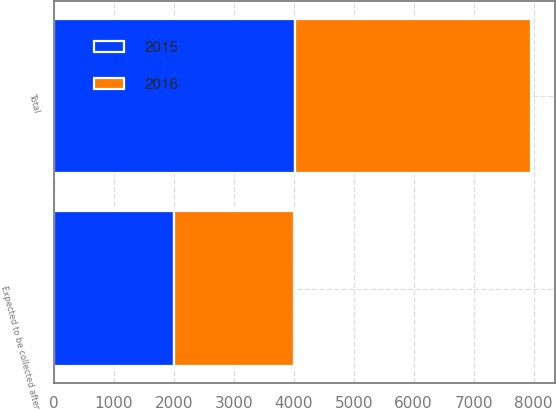Convert chart. <chart><loc_0><loc_0><loc_500><loc_500><stacked_bar_chart><ecel><fcel>Expected to be collected after<fcel>Total<nl><fcel>2016<fcel>2011<fcel>3930<nl><fcel>2015<fcel>2001<fcel>4025<nl></chart> 